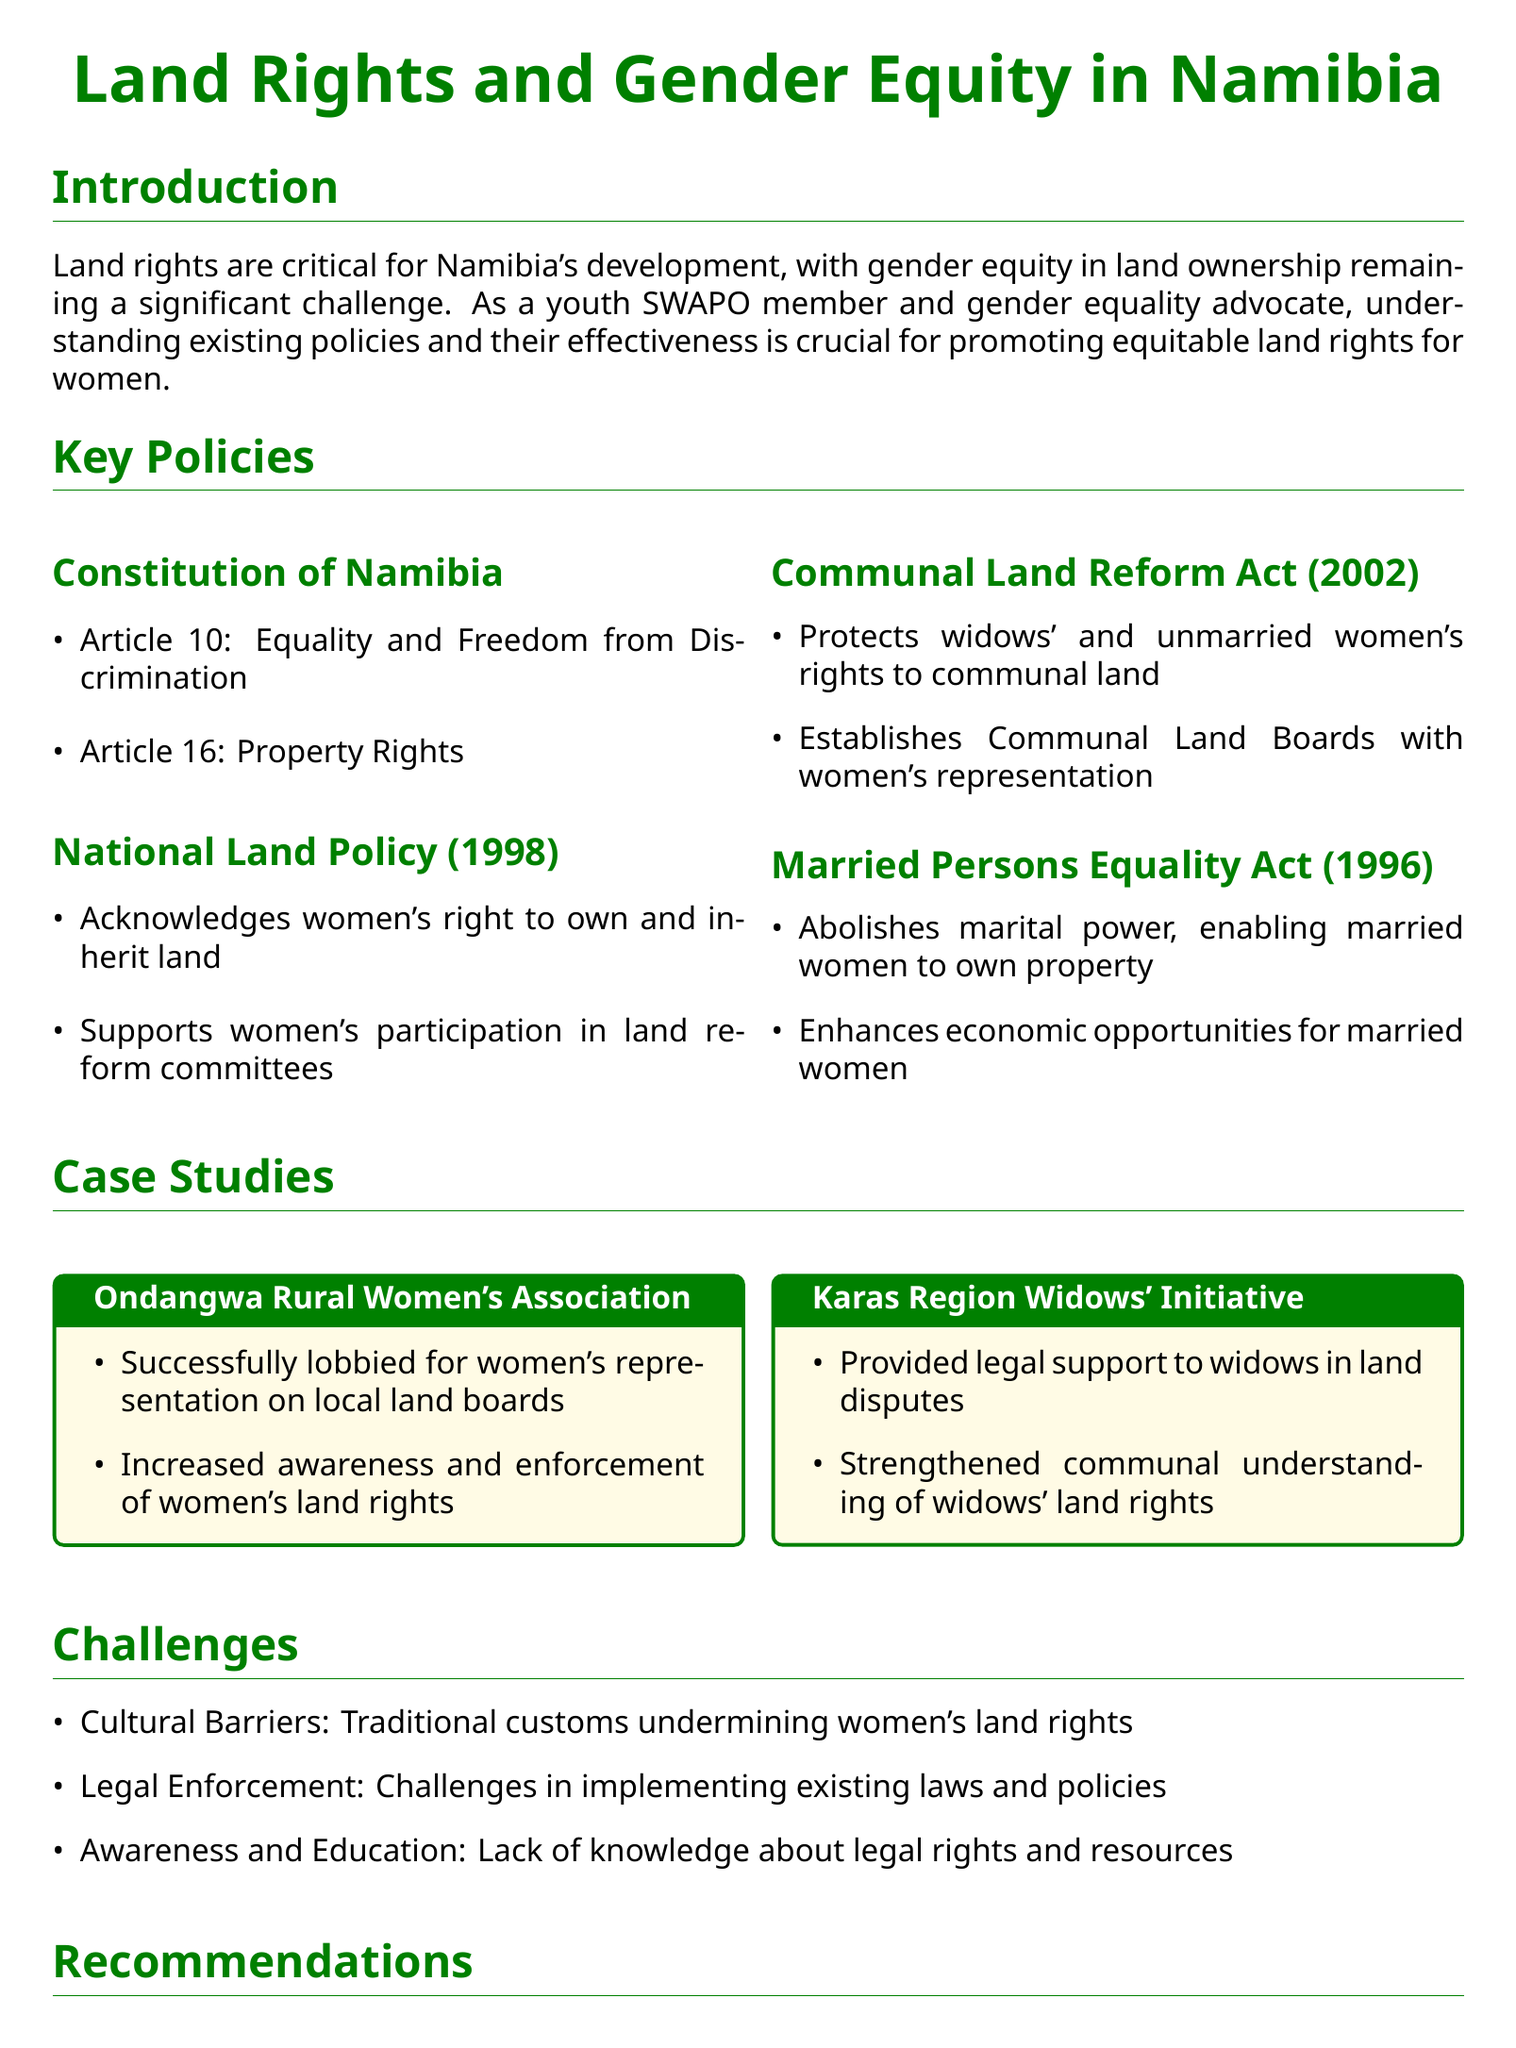What articles in the Constitution of Namibia support gender equality? The Constitution of Namibia includes Article 10 on Equality and Freedom from Discrimination and Article 16 on Property Rights, which support gender equality.
Answer: Article 10 and Article 16 What does the National Land Policy acknowledge? The National Land Policy (1998) acknowledges women's right to own and inherit land and supports women's participation in land reform committees.
Answer: Women's right to own and inherit land What act protects widows' rights to communal land? The Communal Land Reform Act (2002) specifically protects widows' and unmarried women's rights to communal land.
Answer: Communal Land Reform Act What initiative provided legal support to widows? The Karas Region Widows' Initiative provided legal support to widows in land disputes and strengthened communal understanding of widows' land rights.
Answer: Karas Region Widows' Initiative What is a major cultural challenge to women's land rights? Cultural barriers stemming from traditional customs are a significant challenge to women's land rights in Namibia.
Answer: Cultural Barriers What policy reform is recommended for women's land rights? The document recommends strengthening policies protecting women's land rights to enhance their access and ownership.
Answer: Strengthen policies What type of campaigns are suggested to foster awareness? Awareness campaigns are suggested to conduct nationwide education on gender equity in land rights.
Answer: Awareness campaigns What organization successfully lobbied for women's representation on land boards? Ondangwa Rural Women's Association successfully lobbied for women's representation on local land boards and increased awareness of women's land rights.
Answer: Ondangwa Rural Women's Association How many recommendations are made for improving women's access to land? The brief presents three recommendations: policy reform, capacity building, and awareness campaigns.
Answer: Three recommendations 